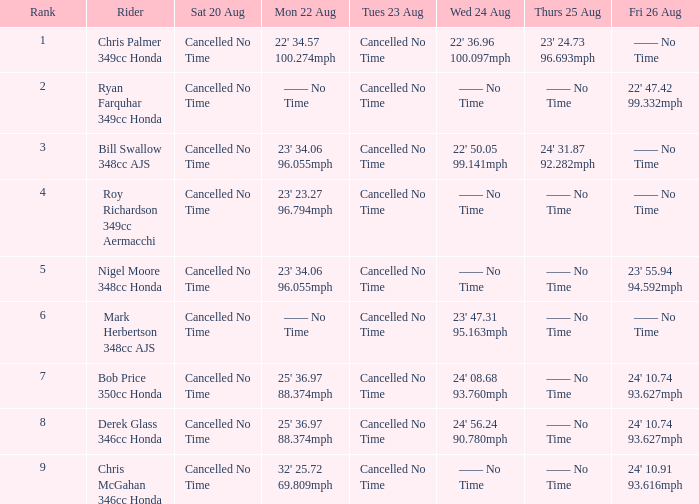282mph? Cancelled No Time. 